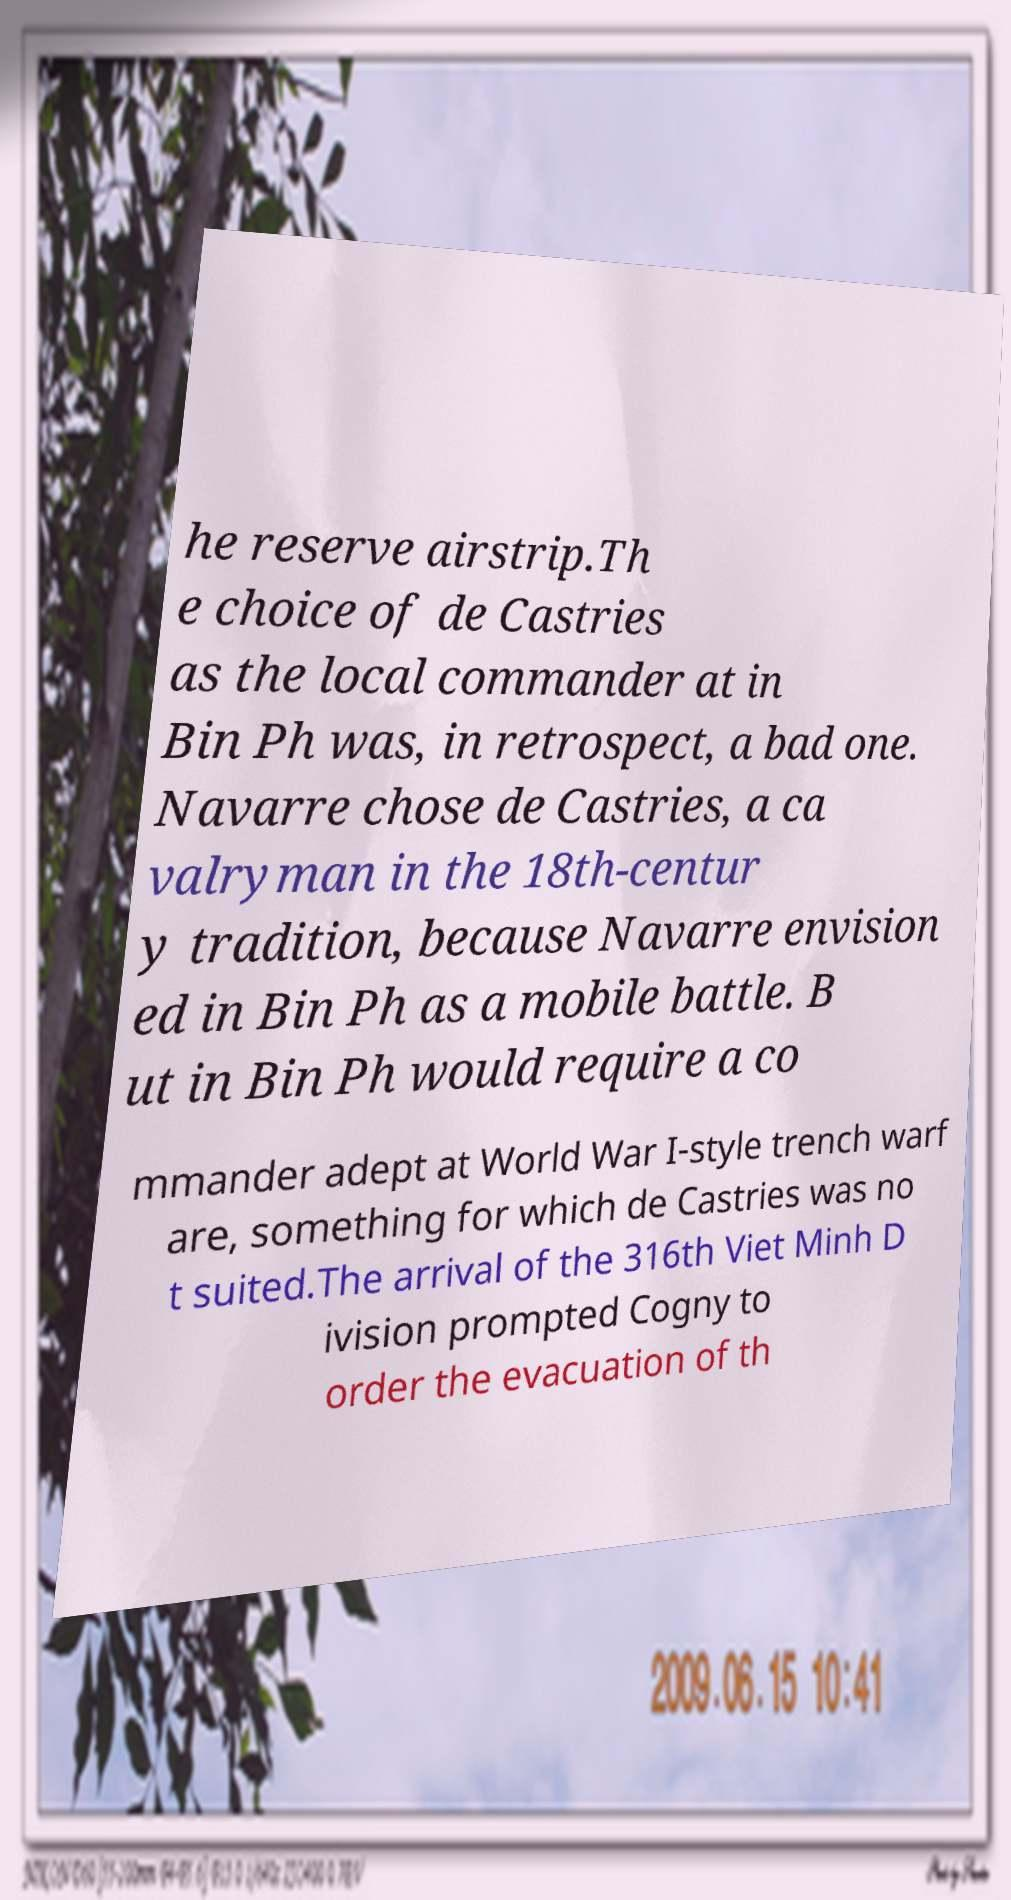Could you extract and type out the text from this image? he reserve airstrip.Th e choice of de Castries as the local commander at in Bin Ph was, in retrospect, a bad one. Navarre chose de Castries, a ca valryman in the 18th-centur y tradition, because Navarre envision ed in Bin Ph as a mobile battle. B ut in Bin Ph would require a co mmander adept at World War I-style trench warf are, something for which de Castries was no t suited.The arrival of the 316th Viet Minh D ivision prompted Cogny to order the evacuation of th 